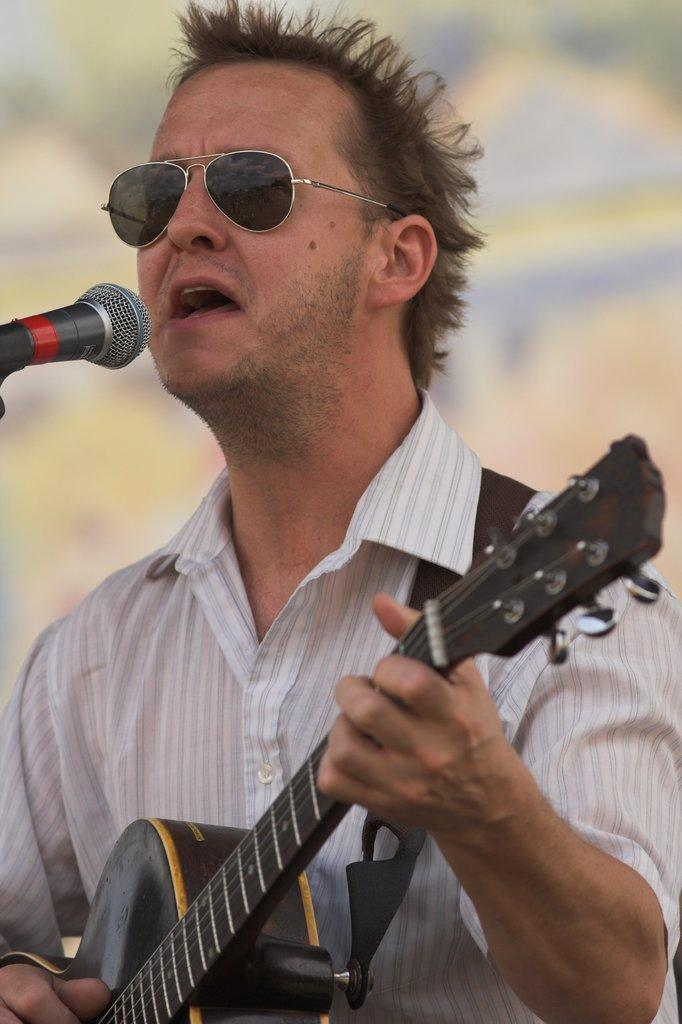What is the man in the image doing? The man is playing a guitar and singing. What is the man wearing in the image? The man is wearing a white shirt and sunglasses. What object is in front of the man? There is a microphone in front of the man. How is the background of the image depicted? The background of the image is blurred. What type of cub can be seen participating in the protest in the image? There is no cub or protest present in the image; it features a man playing a guitar and singing. What type of frame surrounds the image? The provided facts do not mention any frame surrounding the image. 